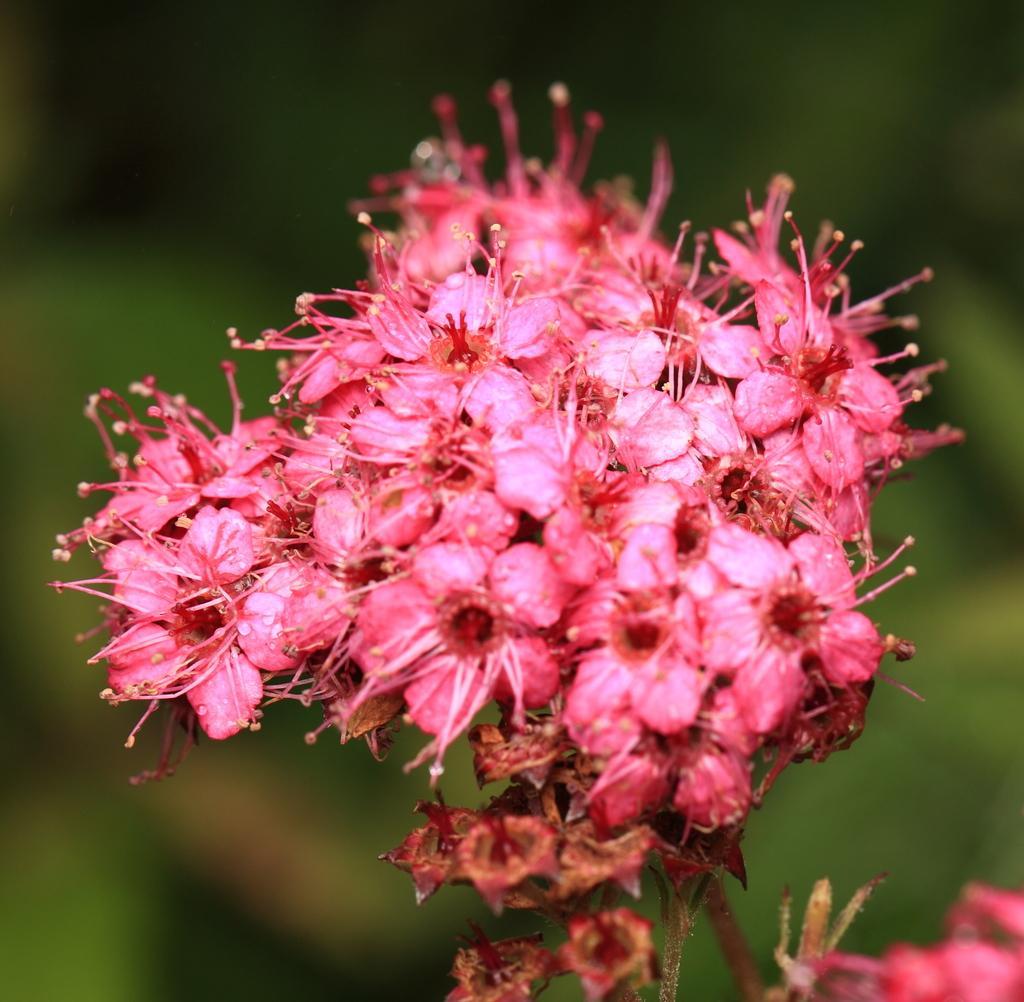Please provide a concise description of this image. In this image we can see flowers and we can also see a blurred background. 